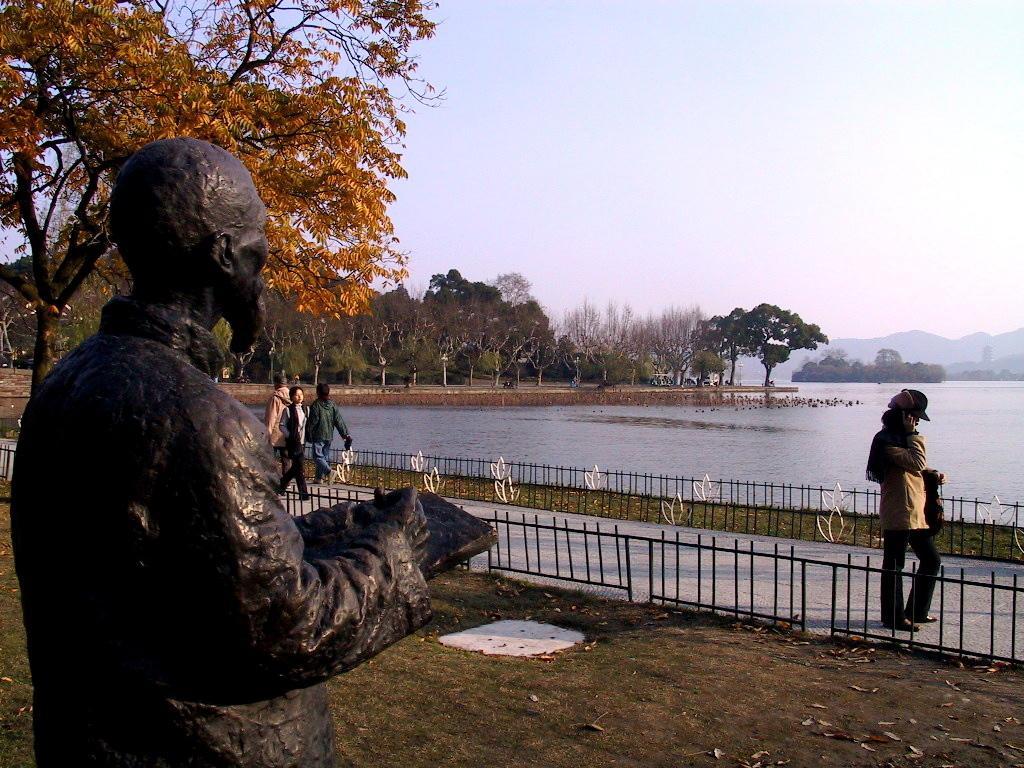Can you describe this image briefly? In this image I can see few persons walking. On the left side I can see a statue. I can see few trees. I can see the water surface. At the top I can see the sky. 